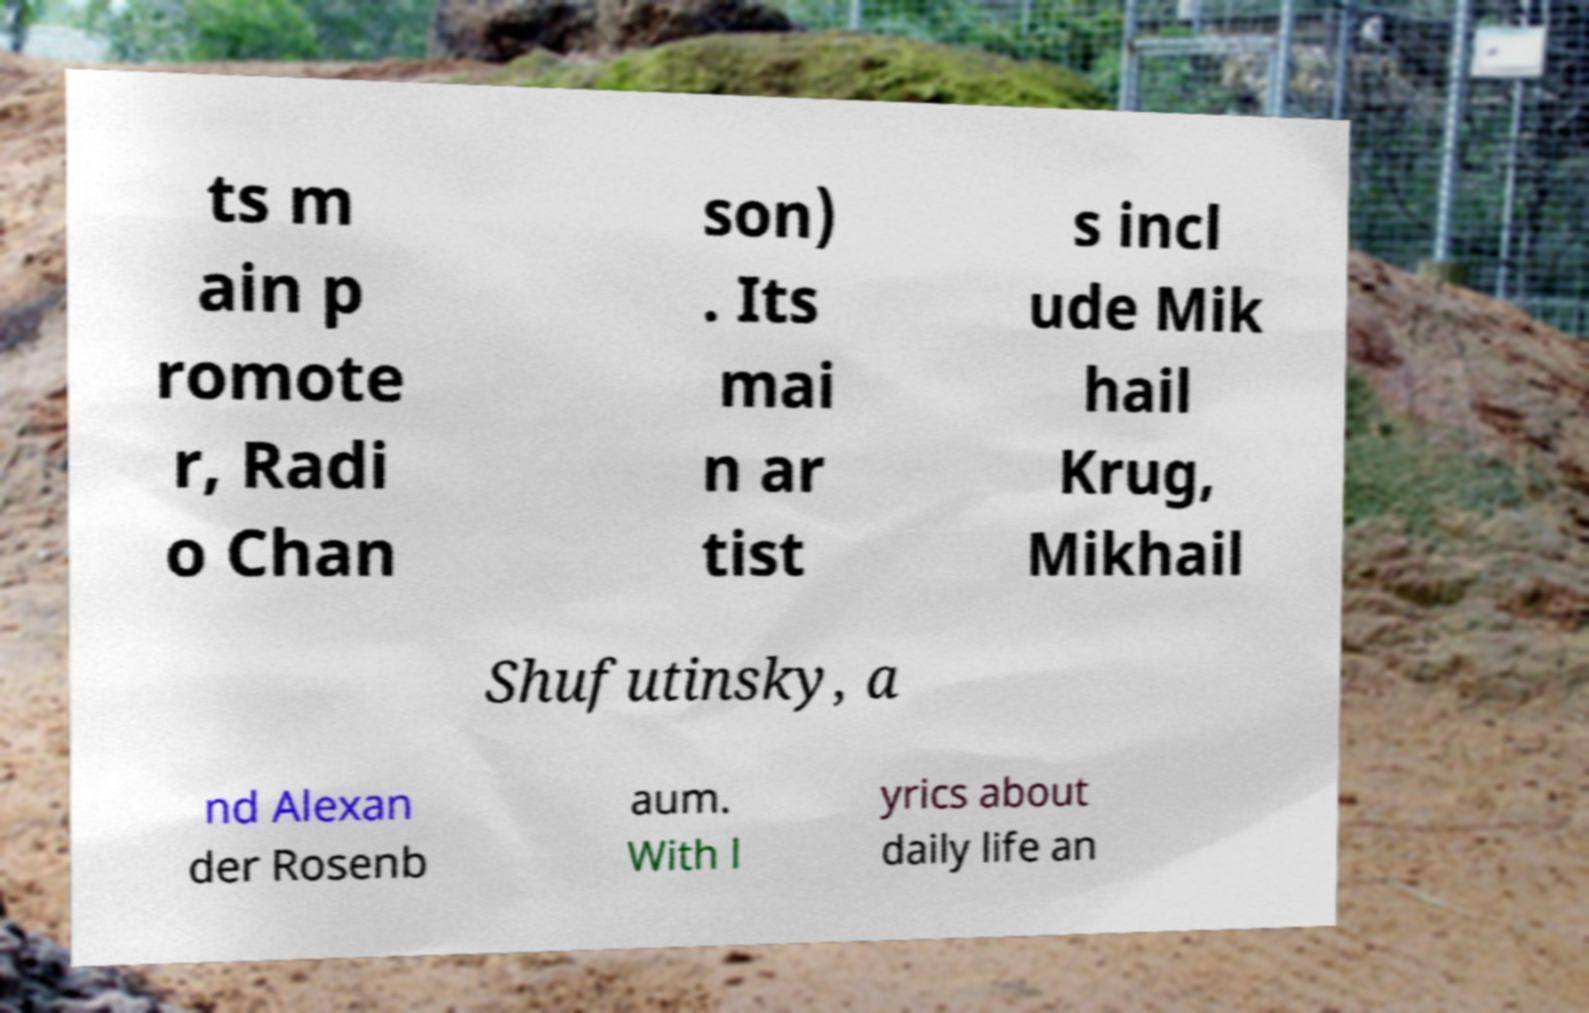Could you extract and type out the text from this image? ts m ain p romote r, Radi o Chan son) . Its mai n ar tist s incl ude Mik hail Krug, Mikhail Shufutinsky, a nd Alexan der Rosenb aum. With l yrics about daily life an 